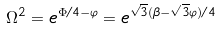<formula> <loc_0><loc_0><loc_500><loc_500>\Omega ^ { 2 } = e ^ { \Phi / 4 - \varphi } = e ^ { \sqrt { 3 } ( \beta - \sqrt { 3 } \varphi ) / 4 }</formula> 